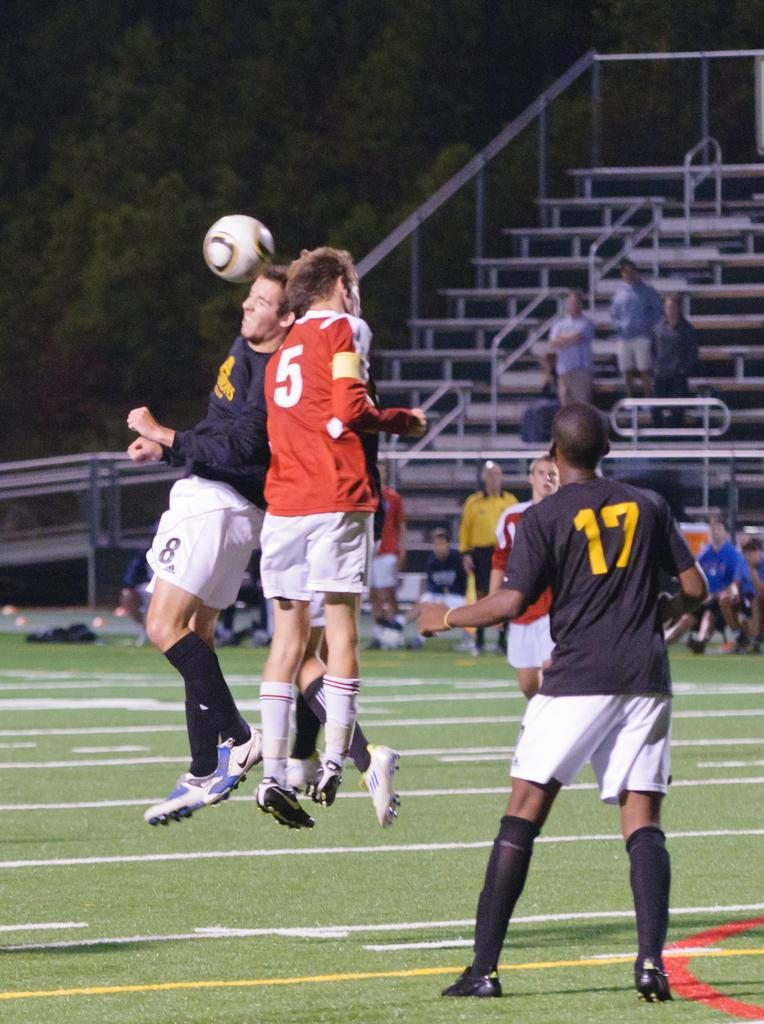<image>
Give a short and clear explanation of the subsequent image. A man with a 5 on his shirt collides with another man while a man with 17 on his shirt watches 